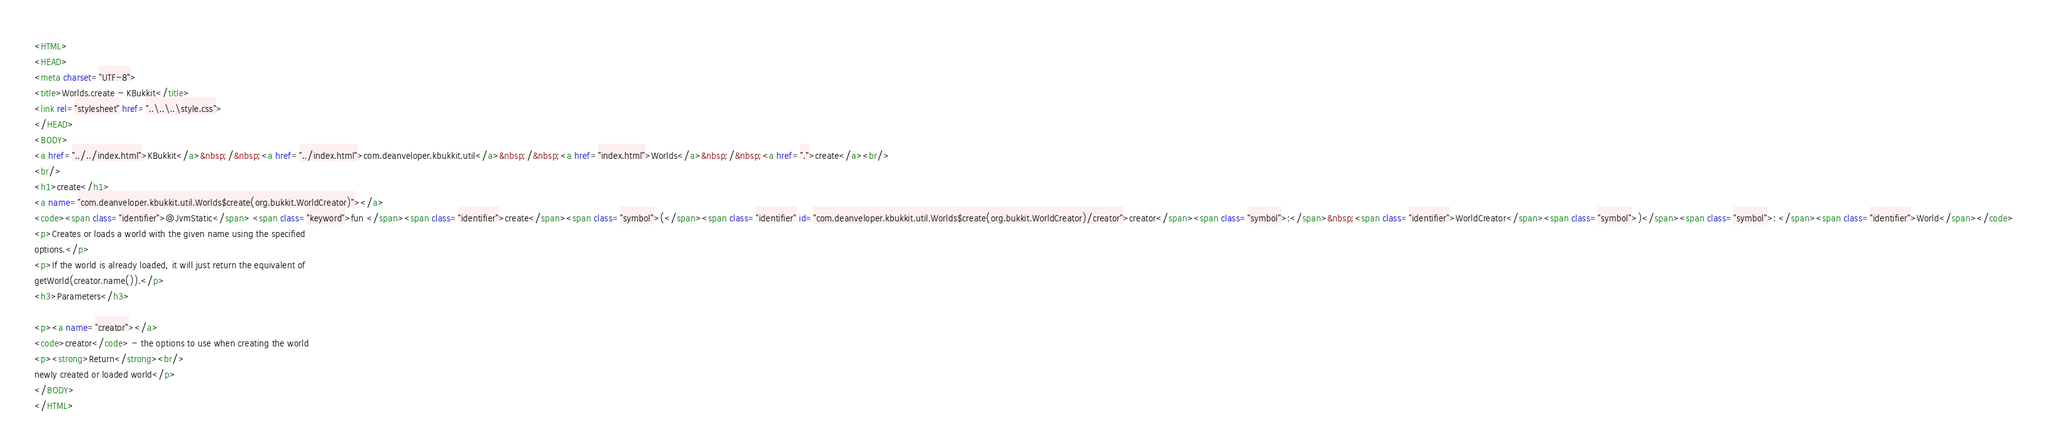<code> <loc_0><loc_0><loc_500><loc_500><_HTML_><HTML>
<HEAD>
<meta charset="UTF-8">
<title>Worlds.create - KBukkit</title>
<link rel="stylesheet" href="..\..\..\style.css">
</HEAD>
<BODY>
<a href="../../index.html">KBukkit</a>&nbsp;/&nbsp;<a href="../index.html">com.deanveloper.kbukkit.util</a>&nbsp;/&nbsp;<a href="index.html">Worlds</a>&nbsp;/&nbsp;<a href=".">create</a><br/>
<br/>
<h1>create</h1>
<a name="com.deanveloper.kbukkit.util.Worlds$create(org.bukkit.WorldCreator)"></a>
<code><span class="identifier">@JvmStatic</span> <span class="keyword">fun </span><span class="identifier">create</span><span class="symbol">(</span><span class="identifier" id="com.deanveloper.kbukkit.util.Worlds$create(org.bukkit.WorldCreator)/creator">creator</span><span class="symbol">:</span>&nbsp;<span class="identifier">WorldCreator</span><span class="symbol">)</span><span class="symbol">: </span><span class="identifier">World</span></code>
<p>Creates or loads a world with the given name using the specified
options.</p>
<p>If the world is already loaded, it will just return the equivalent of
getWorld(creator.name()).</p>
<h3>Parameters</h3>

<p><a name="creator"></a>
<code>creator</code> - the options to use when creating the world
<p><strong>Return</strong><br/>
newly created or loaded world</p>
</BODY>
</HTML>
</code> 